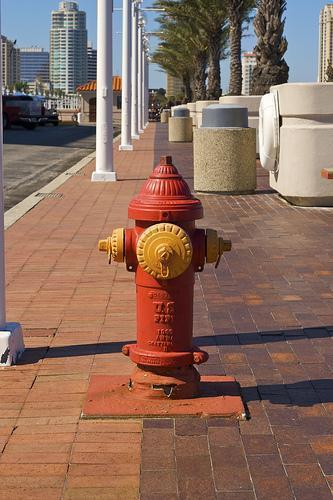How many fire hydrants are in the photo?
Give a very brief answer. 1. How many white poles are visible on the sidewalk?
Give a very brief answer. 5. How many grey top trash cans are visible on the sidewalk?
Give a very brief answer. 3. 